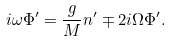Convert formula to latex. <formula><loc_0><loc_0><loc_500><loc_500>i \omega \Phi ^ { \prime } = \frac { g } { M } n ^ { \prime } \mp 2 i \Omega \Phi ^ { \prime } . \\</formula> 